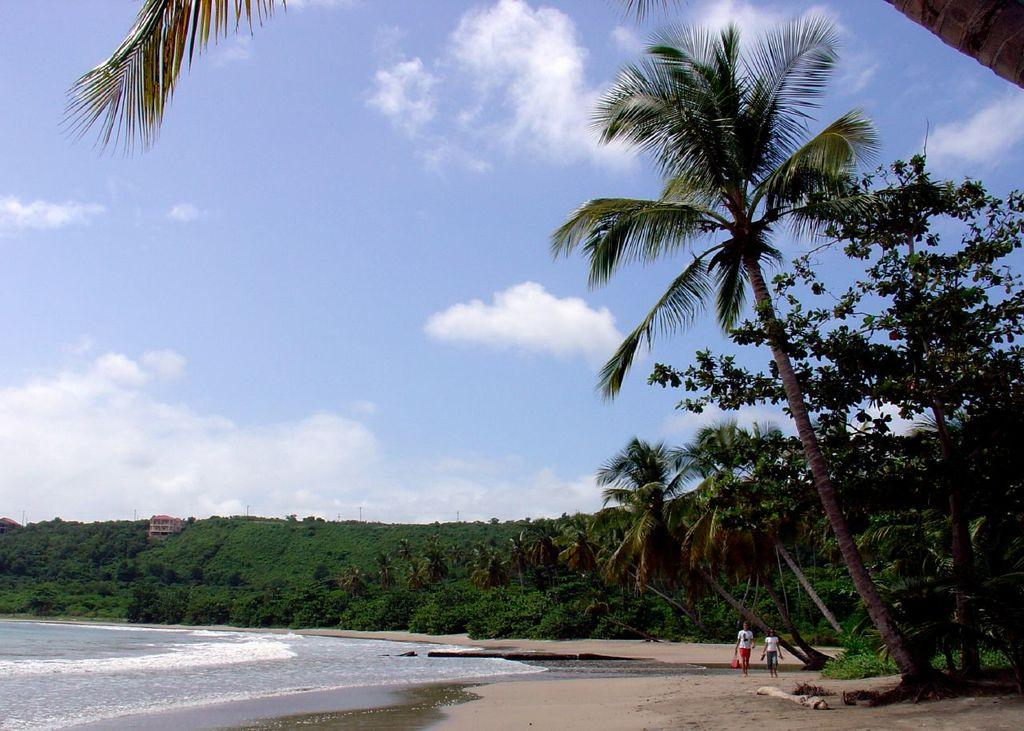What are the two persons in the image doing? The two persons in the image are walking. What can be seen in the background of the image? There is water, green trees, and buildings visible in the background. What is the color of the sky in the image? The sky is blue and white in color. What type of gold circle can be seen in the image? There is no gold circle present in the image. How comfortable are the persons walking in the image? The image does not provide information about the comfort level of the persons walking. 